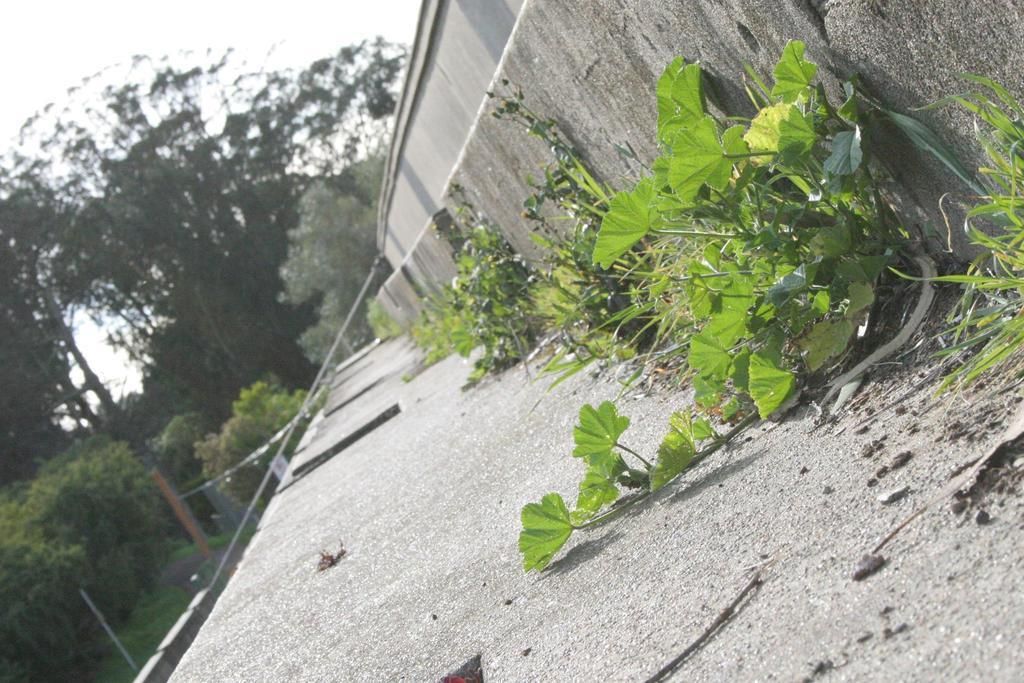What is located in the foreground of the picture? There are plants and a cement construction, possibly a staircase, in the foreground of the picture. What can be seen in the background of the picture? There are trees, a hand railing, and the sky visible in the background of the picture. How much honey is being served by the servant in the image? There is no servant or honey present in the image. What type of gate can be seen in the background of the image? There is no gate present in the image; it features trees, a hand railing, and the sky in the background. 